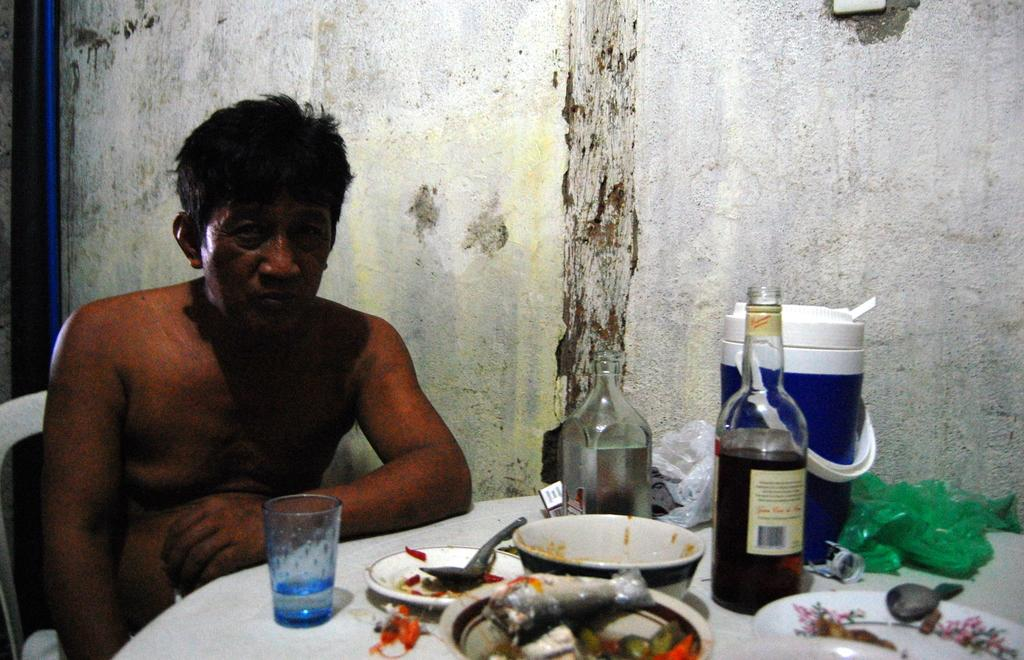What is the person in the image doing? The person is sitting on a chair in the image. What is located in front of the person? The person is in front of a table. What items can be seen on the table? There are two bottles, a bowl, a glass, and an unspecified object on the table. What knowledge can be gained from the town depicted in the image? There is no town depicted in the image, so no knowledge can be gained from it. 